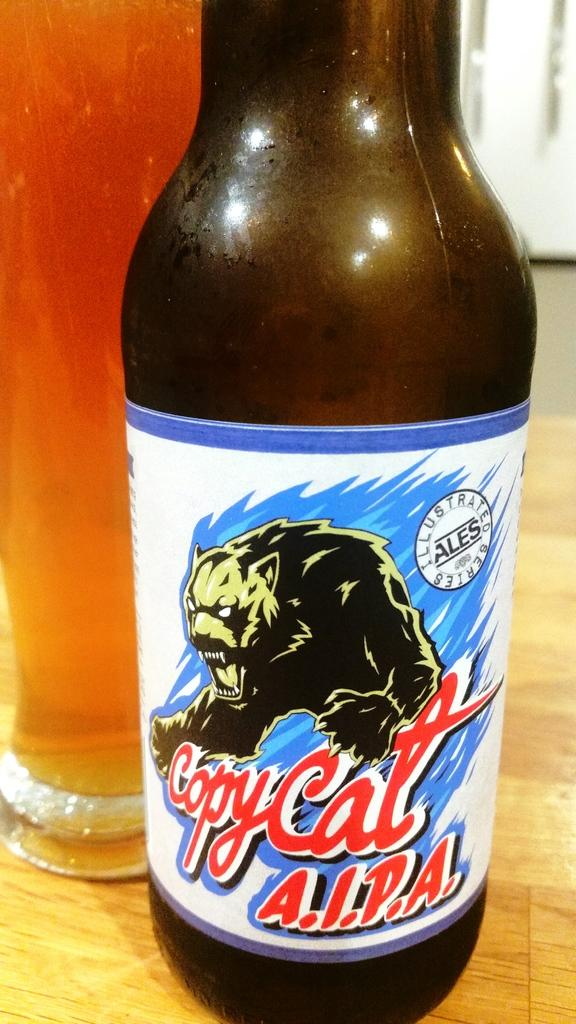<image>
Relay a brief, clear account of the picture shown. A bottle of Copycat A.I.P.A. features a large cat on the label. 